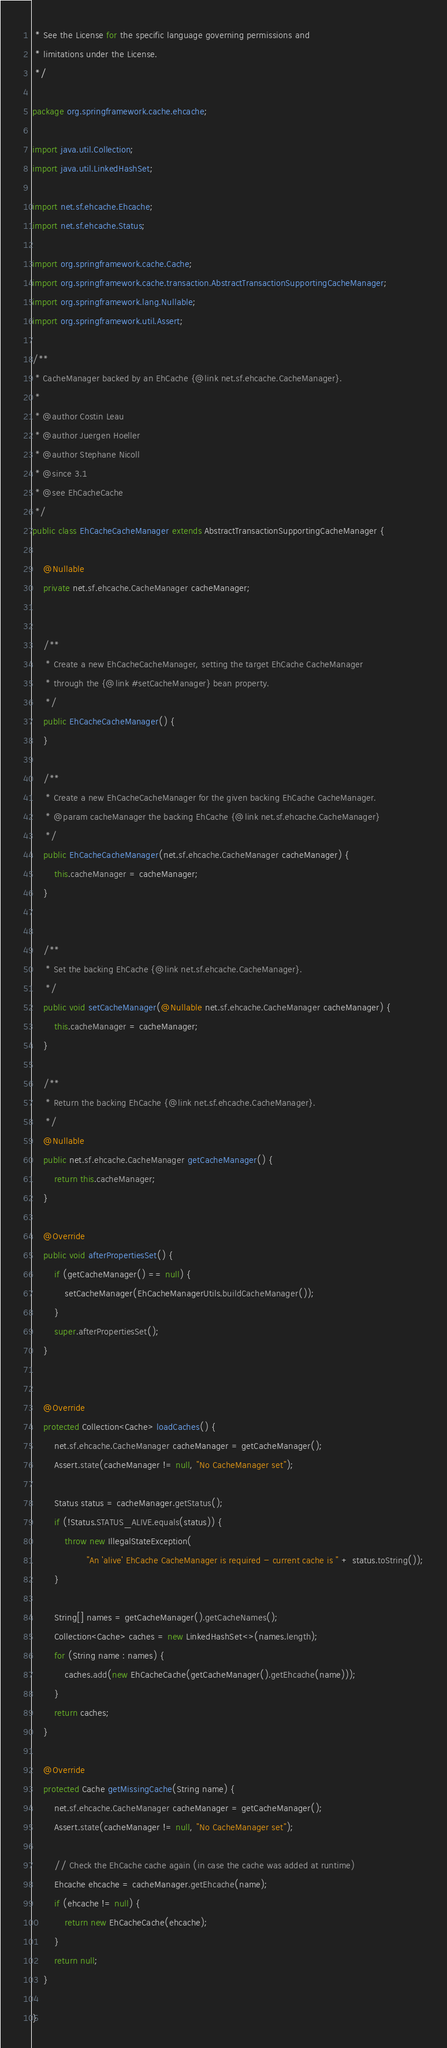Convert code to text. <code><loc_0><loc_0><loc_500><loc_500><_Java_> * See the License for the specific language governing permissions and
 * limitations under the License.
 */

package org.springframework.cache.ehcache;

import java.util.Collection;
import java.util.LinkedHashSet;

import net.sf.ehcache.Ehcache;
import net.sf.ehcache.Status;

import org.springframework.cache.Cache;
import org.springframework.cache.transaction.AbstractTransactionSupportingCacheManager;
import org.springframework.lang.Nullable;
import org.springframework.util.Assert;

/**
 * CacheManager backed by an EhCache {@link net.sf.ehcache.CacheManager}.
 *
 * @author Costin Leau
 * @author Juergen Hoeller
 * @author Stephane Nicoll
 * @since 3.1
 * @see EhCacheCache
 */
public class EhCacheCacheManager extends AbstractTransactionSupportingCacheManager {

	@Nullable
	private net.sf.ehcache.CacheManager cacheManager;


	/**
	 * Create a new EhCacheCacheManager, setting the target EhCache CacheManager
	 * through the {@link #setCacheManager} bean property.
	 */
	public EhCacheCacheManager() {
	}

	/**
	 * Create a new EhCacheCacheManager for the given backing EhCache CacheManager.
	 * @param cacheManager the backing EhCache {@link net.sf.ehcache.CacheManager}
	 */
	public EhCacheCacheManager(net.sf.ehcache.CacheManager cacheManager) {
		this.cacheManager = cacheManager;
	}


	/**
	 * Set the backing EhCache {@link net.sf.ehcache.CacheManager}.
	 */
	public void setCacheManager(@Nullable net.sf.ehcache.CacheManager cacheManager) {
		this.cacheManager = cacheManager;
	}

	/**
	 * Return the backing EhCache {@link net.sf.ehcache.CacheManager}.
	 */
	@Nullable
	public net.sf.ehcache.CacheManager getCacheManager() {
		return this.cacheManager;
	}

	@Override
	public void afterPropertiesSet() {
		if (getCacheManager() == null) {
			setCacheManager(EhCacheManagerUtils.buildCacheManager());
		}
		super.afterPropertiesSet();
	}


	@Override
	protected Collection<Cache> loadCaches() {
		net.sf.ehcache.CacheManager cacheManager = getCacheManager();
		Assert.state(cacheManager != null, "No CacheManager set");

		Status status = cacheManager.getStatus();
		if (!Status.STATUS_ALIVE.equals(status)) {
			throw new IllegalStateException(
					"An 'alive' EhCache CacheManager is required - current cache is " + status.toString());
		}

		String[] names = getCacheManager().getCacheNames();
		Collection<Cache> caches = new LinkedHashSet<>(names.length);
		for (String name : names) {
			caches.add(new EhCacheCache(getCacheManager().getEhcache(name)));
		}
		return caches;
	}

	@Override
	protected Cache getMissingCache(String name) {
		net.sf.ehcache.CacheManager cacheManager = getCacheManager();
		Assert.state(cacheManager != null, "No CacheManager set");

		// Check the EhCache cache again (in case the cache was added at runtime)
		Ehcache ehcache = cacheManager.getEhcache(name);
		if (ehcache != null) {
			return new EhCacheCache(ehcache);
		}
		return null;
	}

}
</code> 